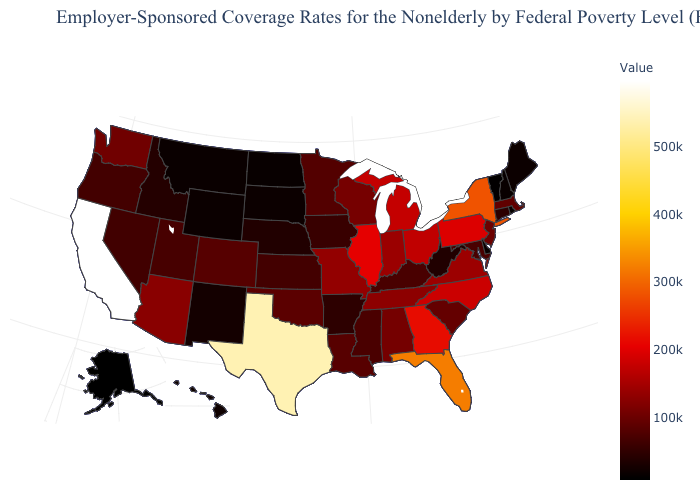Does Alaska have the lowest value in the USA?
Answer briefly. Yes. Does Hawaii have the lowest value in the West?
Concise answer only. No. Among the states that border Florida , does Alabama have the lowest value?
Short answer required. Yes. Which states hav the highest value in the South?
Write a very short answer. Texas. Does North Dakota have the highest value in the USA?
Answer briefly. No. Is the legend a continuous bar?
Write a very short answer. Yes. 